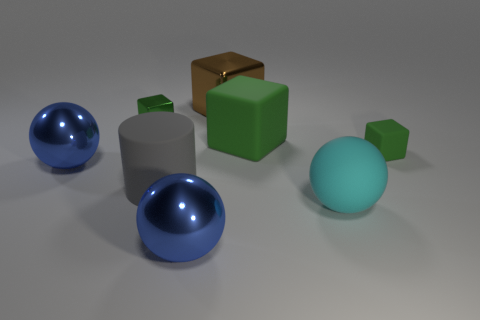Subtract all brown balls. How many green cubes are left? 3 Subtract all gray spheres. Subtract all brown cubes. How many spheres are left? 3 Add 1 red metallic cylinders. How many objects exist? 9 Subtract all cylinders. How many objects are left? 7 Subtract 0 blue cylinders. How many objects are left? 8 Subtract all large cyan things. Subtract all big cyan spheres. How many objects are left? 6 Add 1 small green metallic cubes. How many small green metallic cubes are left? 2 Add 3 large matte cylinders. How many large matte cylinders exist? 4 